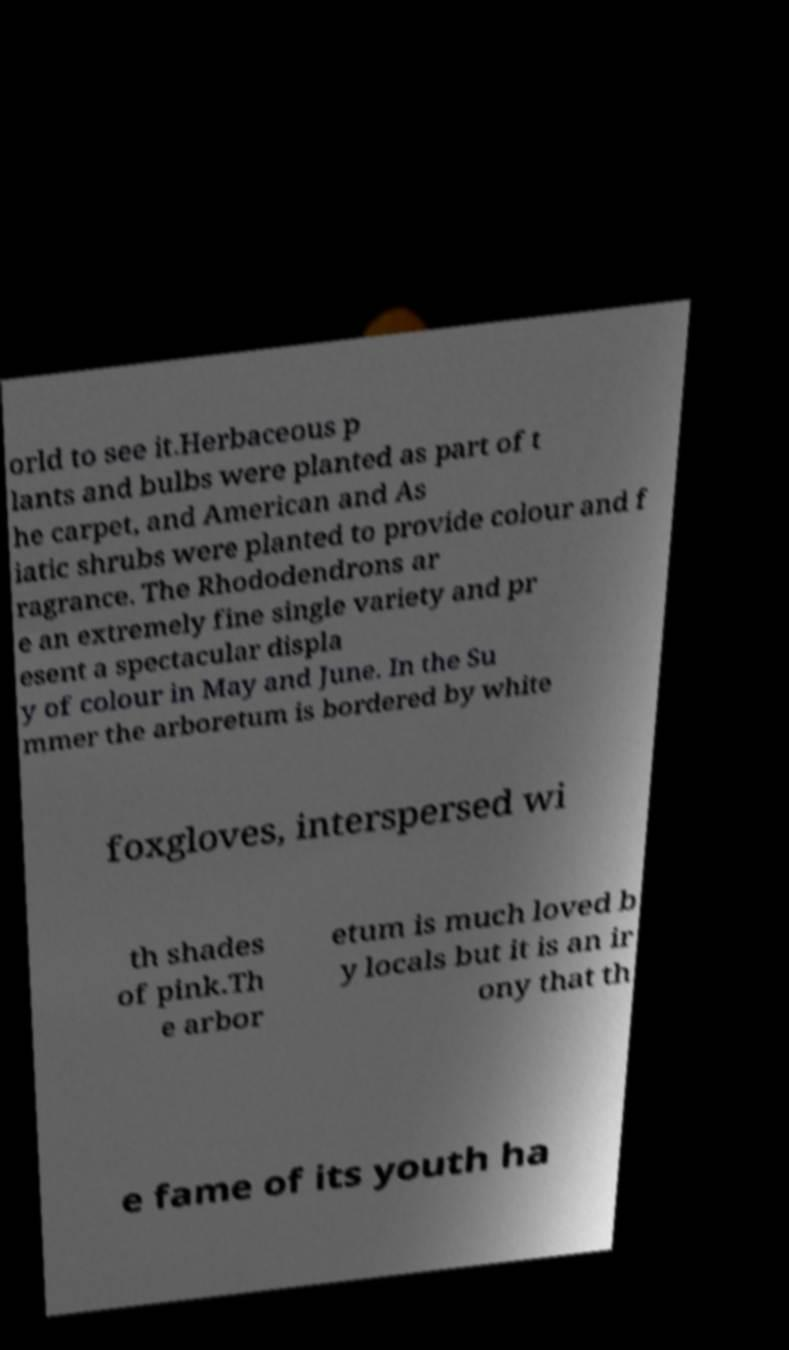There's text embedded in this image that I need extracted. Can you transcribe it verbatim? orld to see it.Herbaceous p lants and bulbs were planted as part of t he carpet, and American and As iatic shrubs were planted to provide colour and f ragrance. The Rhododendrons ar e an extremely fine single variety and pr esent a spectacular displa y of colour in May and June. In the Su mmer the arboretum is bordered by white foxgloves, interspersed wi th shades of pink.Th e arbor etum is much loved b y locals but it is an ir ony that th e fame of its youth ha 